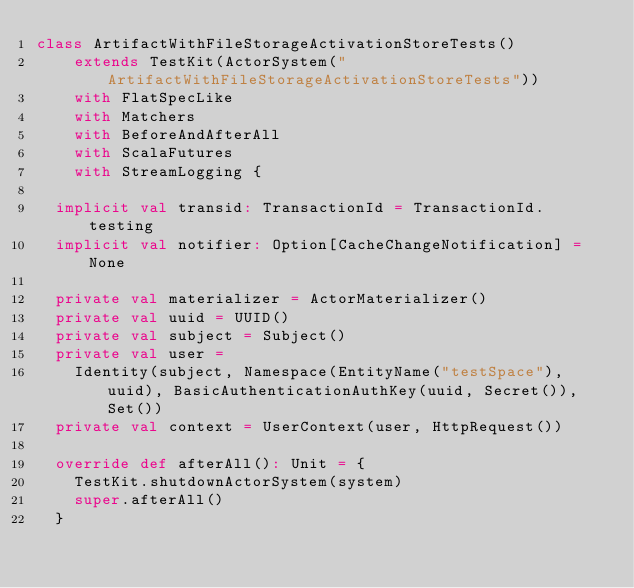<code> <loc_0><loc_0><loc_500><loc_500><_Scala_>class ArtifactWithFileStorageActivationStoreTests()
    extends TestKit(ActorSystem("ArtifactWithFileStorageActivationStoreTests"))
    with FlatSpecLike
    with Matchers
    with BeforeAndAfterAll
    with ScalaFutures
    with StreamLogging {

  implicit val transid: TransactionId = TransactionId.testing
  implicit val notifier: Option[CacheChangeNotification] = None

  private val materializer = ActorMaterializer()
  private val uuid = UUID()
  private val subject = Subject()
  private val user =
    Identity(subject, Namespace(EntityName("testSpace"), uuid), BasicAuthenticationAuthKey(uuid, Secret()), Set())
  private val context = UserContext(user, HttpRequest())

  override def afterAll(): Unit = {
    TestKit.shutdownActorSystem(system)
    super.afterAll()
  }
</code> 